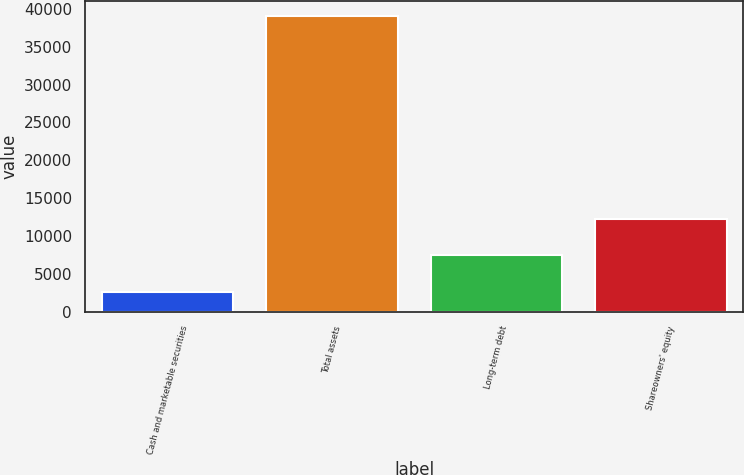Convert chart to OTSL. <chart><loc_0><loc_0><loc_500><loc_500><bar_chart><fcel>Cash and marketable securities<fcel>Total assets<fcel>Long-term debt<fcel>Shareowners' equity<nl><fcel>2604<fcel>39042<fcel>7506<fcel>12183<nl></chart> 